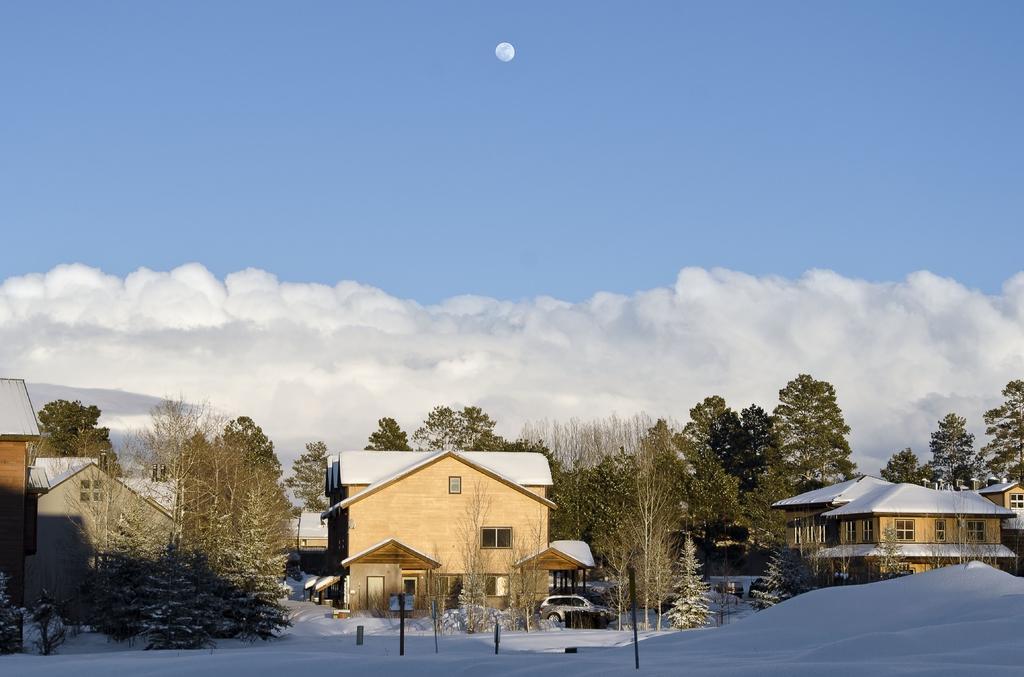In one or two sentences, can you explain what this image depicts? In this image, there are a few houses, trees and plants. We can see the ground covered with snow and some objects. We can also see a vehicle and some poles. We can also see the sky with clouds. 